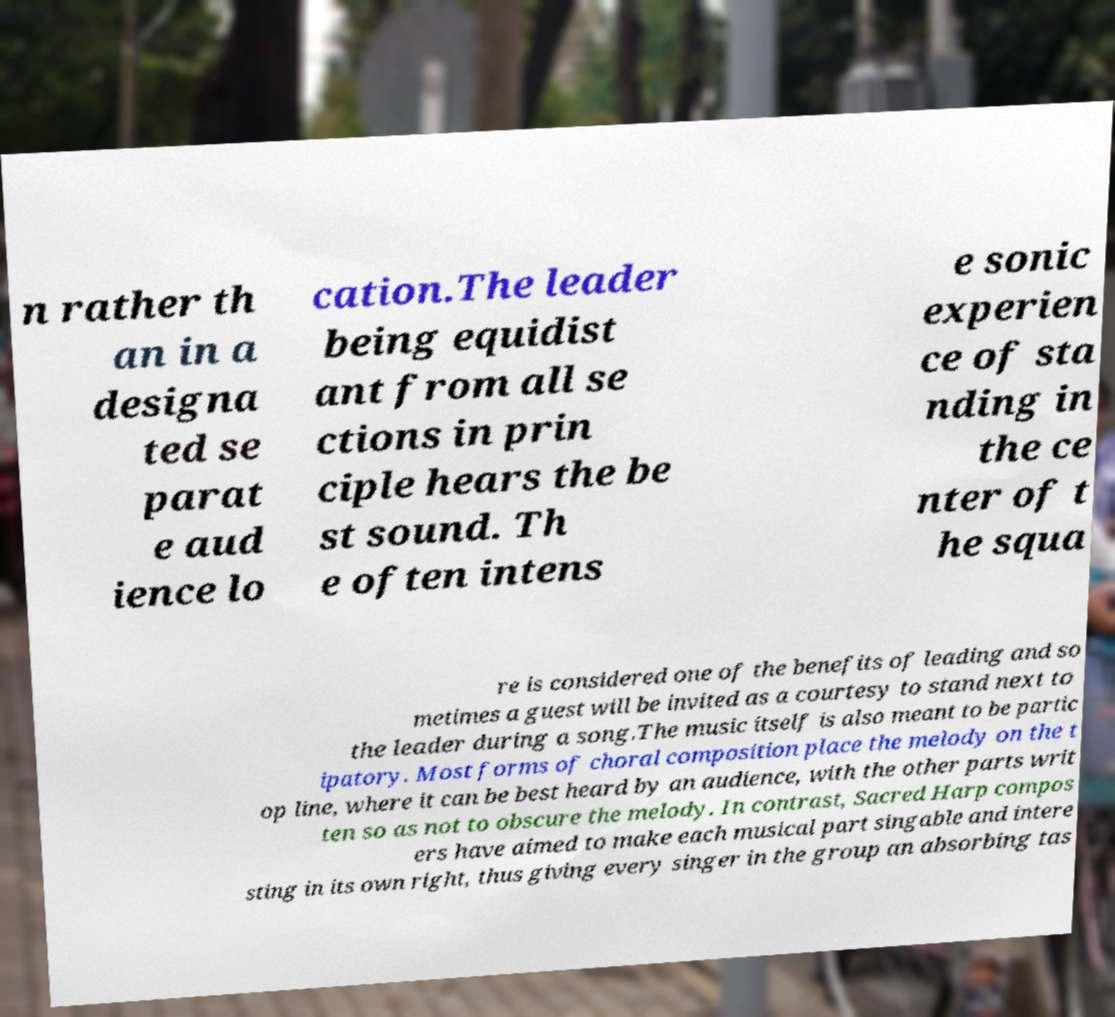Could you assist in decoding the text presented in this image and type it out clearly? n rather th an in a designa ted se parat e aud ience lo cation.The leader being equidist ant from all se ctions in prin ciple hears the be st sound. Th e often intens e sonic experien ce of sta nding in the ce nter of t he squa re is considered one of the benefits of leading and so metimes a guest will be invited as a courtesy to stand next to the leader during a song.The music itself is also meant to be partic ipatory. Most forms of choral composition place the melody on the t op line, where it can be best heard by an audience, with the other parts writ ten so as not to obscure the melody. In contrast, Sacred Harp compos ers have aimed to make each musical part singable and intere sting in its own right, thus giving every singer in the group an absorbing tas 